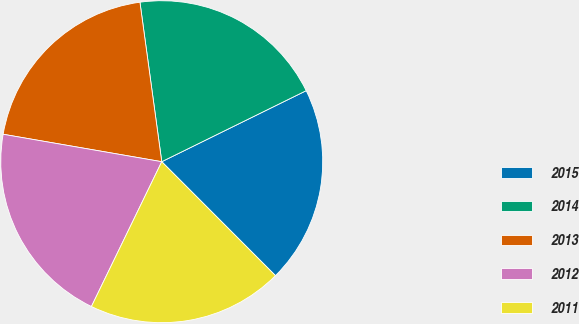Convert chart to OTSL. <chart><loc_0><loc_0><loc_500><loc_500><pie_chart><fcel>2015<fcel>2014<fcel>2013<fcel>2012<fcel>2011<nl><fcel>19.79%<fcel>19.89%<fcel>20.11%<fcel>20.53%<fcel>19.68%<nl></chart> 